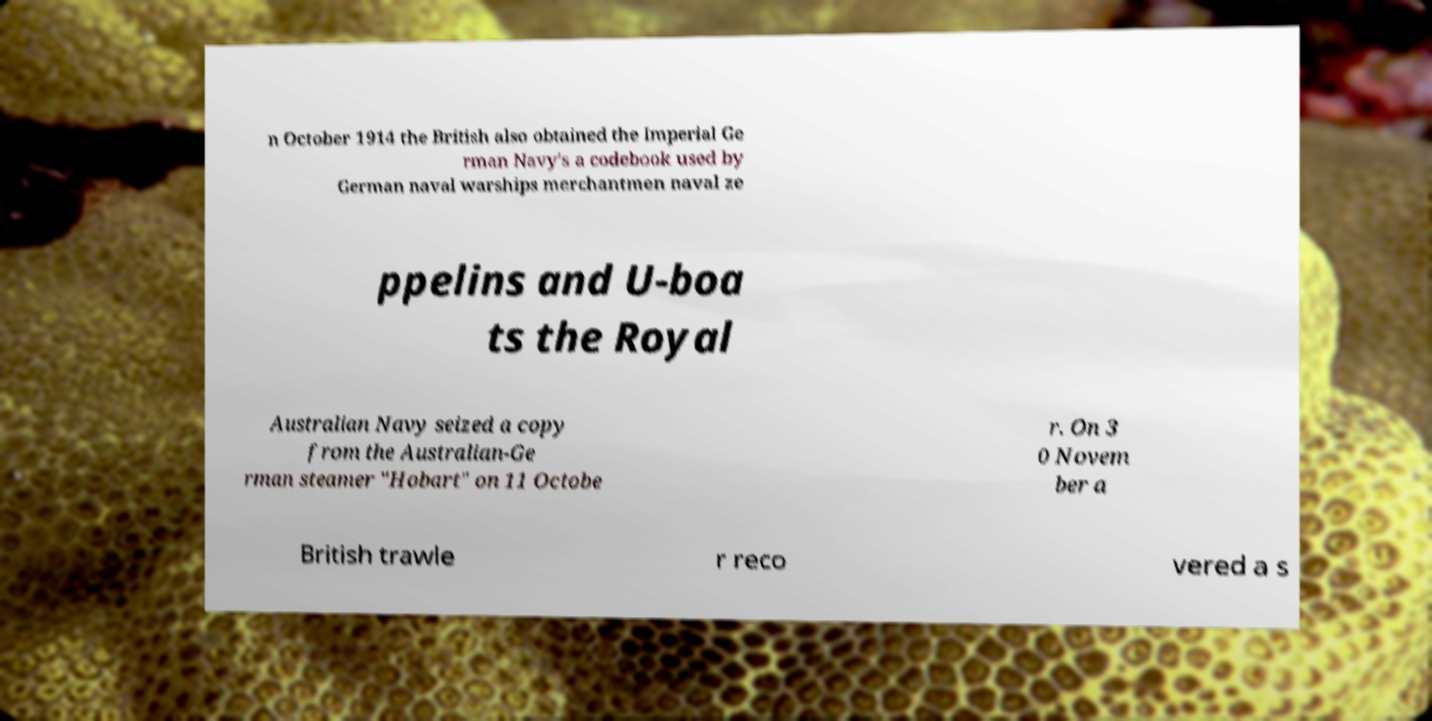For documentation purposes, I need the text within this image transcribed. Could you provide that? n October 1914 the British also obtained the Imperial Ge rman Navy's a codebook used by German naval warships merchantmen naval ze ppelins and U-boa ts the Royal Australian Navy seized a copy from the Australian-Ge rman steamer "Hobart" on 11 Octobe r. On 3 0 Novem ber a British trawle r reco vered a s 